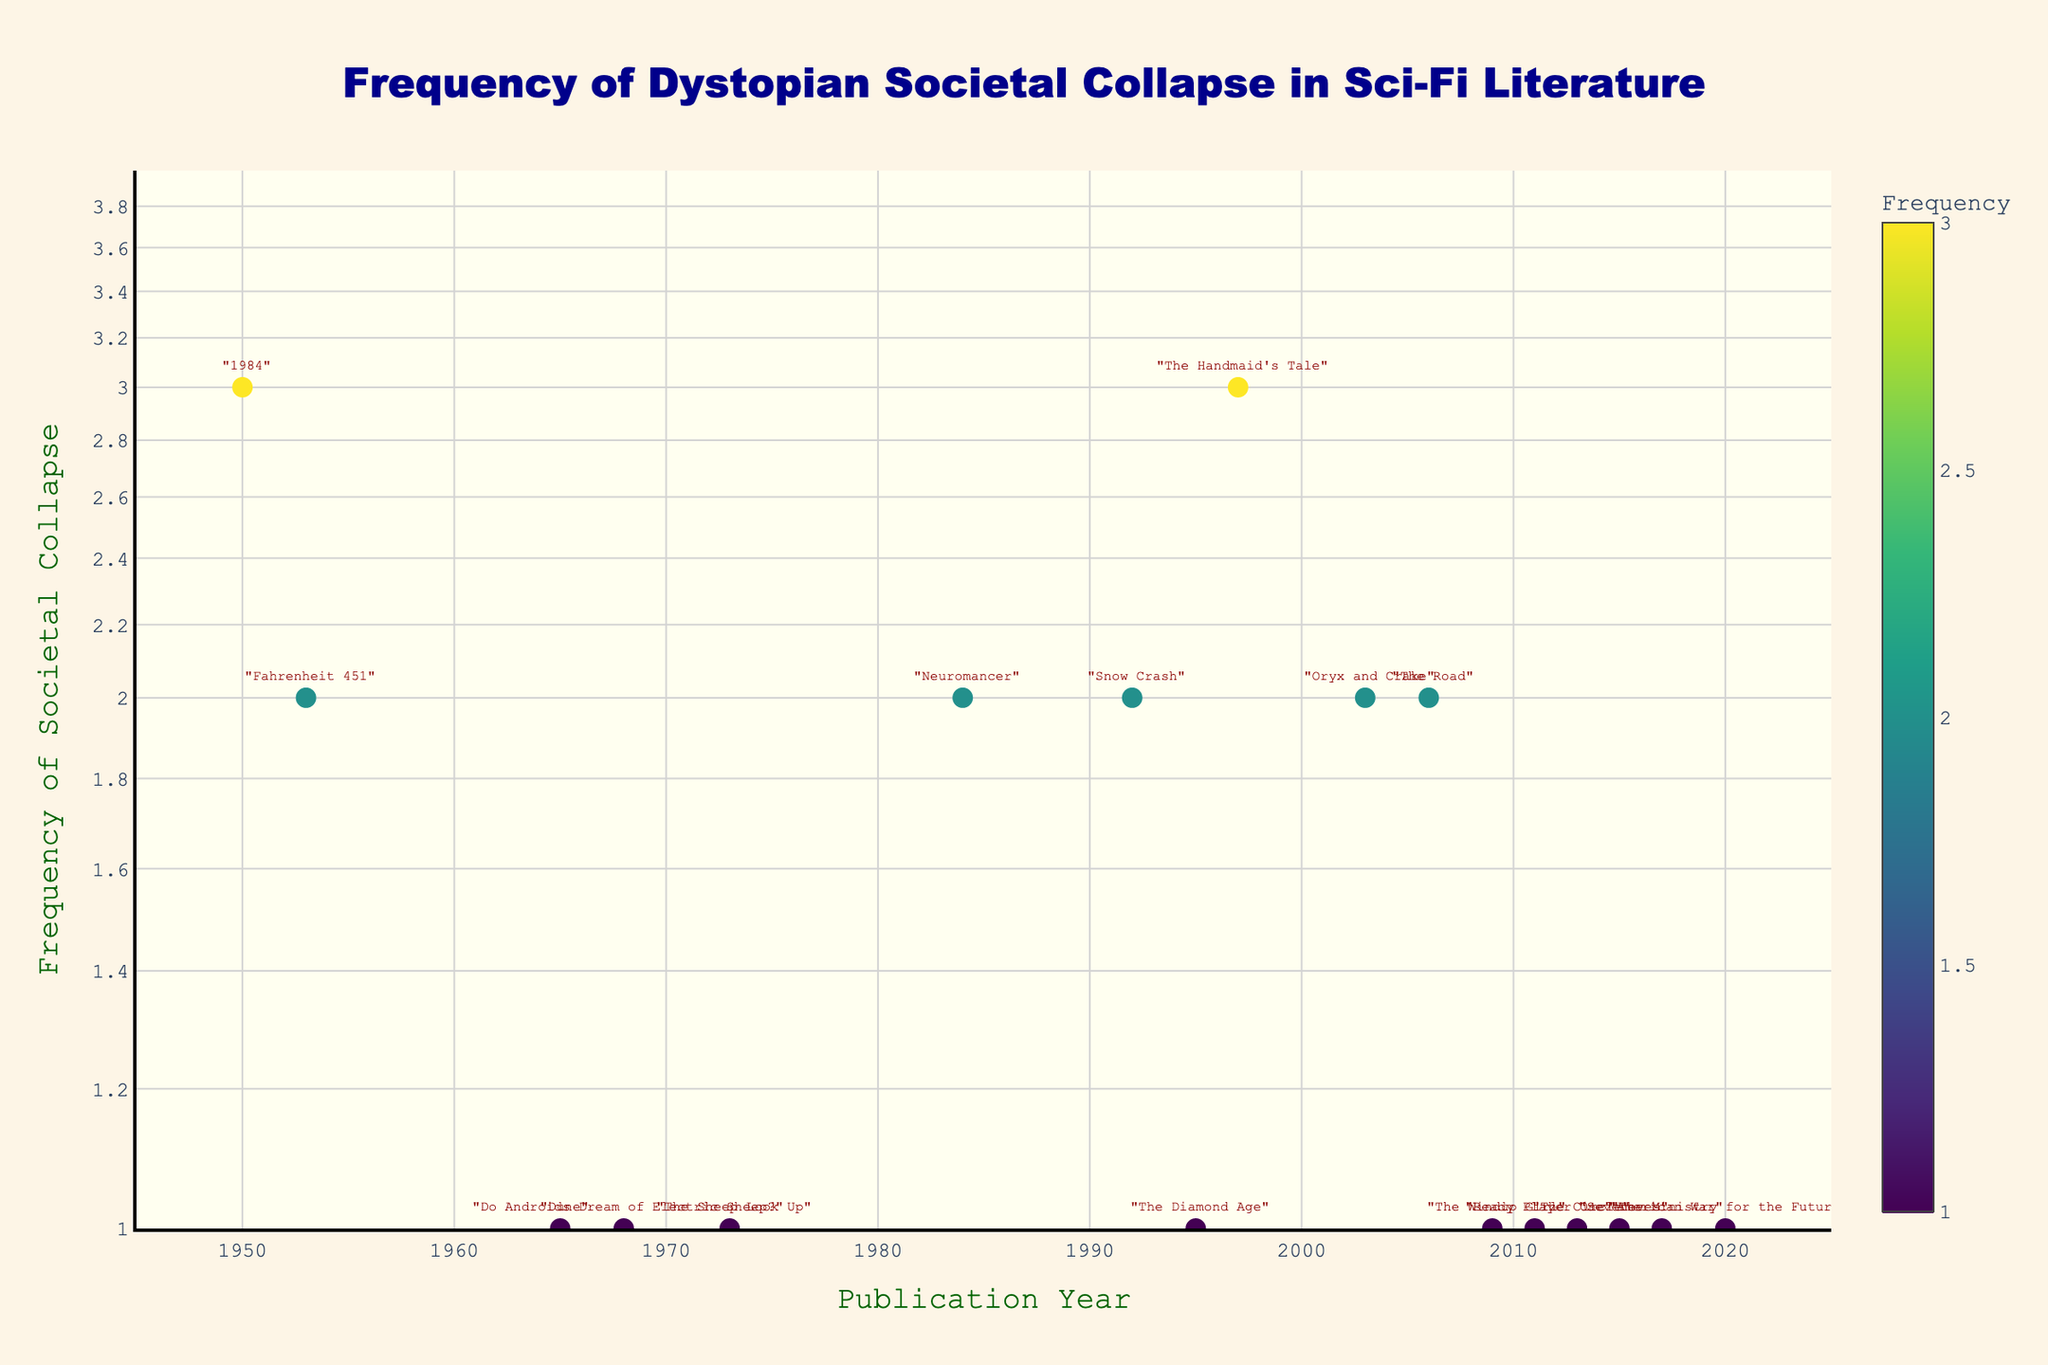What is the title of the plot? The title of the plot is displayed at the top in a large, blue font.
Answer: Frequency of Dystopian Societal Collapse in Sci-Fi Literature What is the color used for the plot background? The plot background color is provided for better contrast and is mentioned in the code snippets.
Answer: Ivory Which publication year has the highest frequency of dystopian societal collapse? By observing the y-axis (which is on a log scale) and the size of the markers, the years 1997, 1950, and 1953 have the highest value (3).
Answer: 1997, 1950, 1953 What is the y-axis label and its scale type? The y-axis label indicates what the y-values represent in the plot, and the type of scale is mentioned explicitly.
Answer: Frequency of Societal Collapse, log scale How many books are represented in the plot? Each book corresponds to one data point. Counting the markers on the scatter plot gives the total number of books.
Answer: 17 Which year has the lowest frequency of societal collapse shown in the figure? The y-values and the log scale make it easy to determine the minimum frequency, which is 1, occurring in multiple years.
Answer: 1965, 1968, 1973, 1995, 2009, 2011, 2013, 2015, 2017, 2020 Compare the frequency of dystopian societal collapse between "1984" and "The Handmaid's Tale". Both titles can be found by following their markers on the plot. Both "1984" (year 1950) and "The Handmaid's Tale" (year 1997) have a frequency of 3.
Answer: They are the same What is the average frequency of societal collapse for books published after 2000? Identify books published after 2000, sum their frequencies, and divide by the number of such books (2+2+1+1+1+1+1).
Answer: (2+2+1+1+1+1+1)/7 = 1.29 In which decade did the publication of books with a frequency of 2 occur most frequently? Analyze the decades on the plot and count how many times each decade appears with a frequency of 2. The decade with the most occurrences is the answer.
Answer: 2000s: 3 books (2003, 2006, 2009) What is the median frequency of societal collapse for all the books in the plot? Collect all frequencies, sort them, and find the middle value. The median is the middle value of a sorted list of frequencies.
Answer: Median = 1 (sorted frequencies: 1,1,1,1,1,1,1,1,1,1,2,2,2,2,2,3,3) 